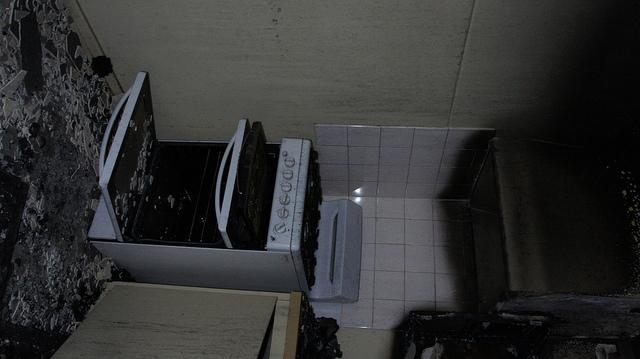Is the orientation of this picture correct?
Concise answer only. No. Does the door shown have a lock?
Answer briefly. No. Are the stove doors open or closed?
Give a very brief answer. Open. What color are the fixtures?
Keep it brief. White. What color is the backsplash?
Quick response, please. White. What time of day is it in this photo?
Keep it brief. Night. Where is this found?
Give a very brief answer. Kitchen. Is there a dishwasher in this room?
Give a very brief answer. No. Which boat has water in the bottom?
Concise answer only. None. What is the metal object on the lower right called?
Short answer required. Oven. Is the sun shining?
Concise answer only. No. Where is the camera man standing?
Write a very short answer. Kitchen. Is there a brown suitcase?
Short answer required. No. How many stairs are in the picture?
Be succinct. 0. How many knobs can be seen on the stove?
Write a very short answer. 6. What kind of oven is this?
Answer briefly. Gas. 